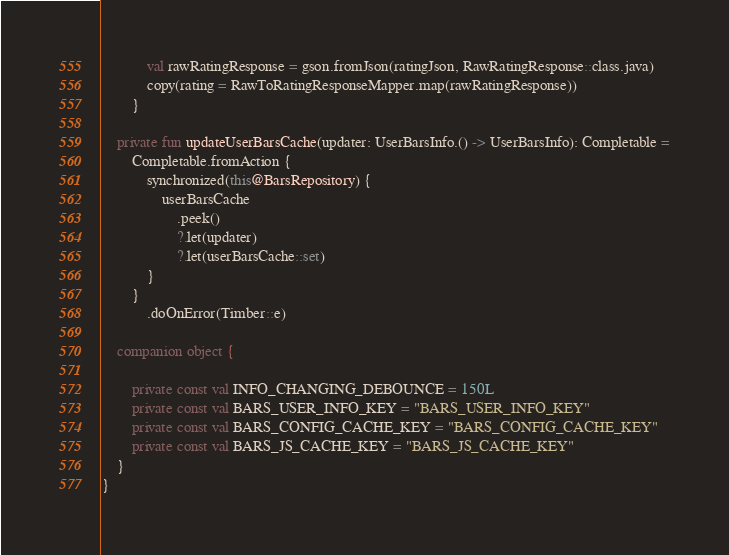Convert code to text. <code><loc_0><loc_0><loc_500><loc_500><_Kotlin_>            val rawRatingResponse = gson.fromJson(ratingJson, RawRatingResponse::class.java)
            copy(rating = RawToRatingResponseMapper.map(rawRatingResponse))
        }

    private fun updateUserBarsCache(updater: UserBarsInfo.() -> UserBarsInfo): Completable =
        Completable.fromAction {
            synchronized(this@BarsRepository) {
                userBarsCache
                    .peek()
                    ?.let(updater)
                    ?.let(userBarsCache::set)
            }
        }
            .doOnError(Timber::e)

    companion object {

        private const val INFO_CHANGING_DEBOUNCE = 150L
        private const val BARS_USER_INFO_KEY = "BARS_USER_INFO_KEY"
        private const val BARS_CONFIG_CACHE_KEY = "BARS_CONFIG_CACHE_KEY"
        private const val BARS_JS_CACHE_KEY = "BARS_JS_CACHE_KEY"
    }
}</code> 